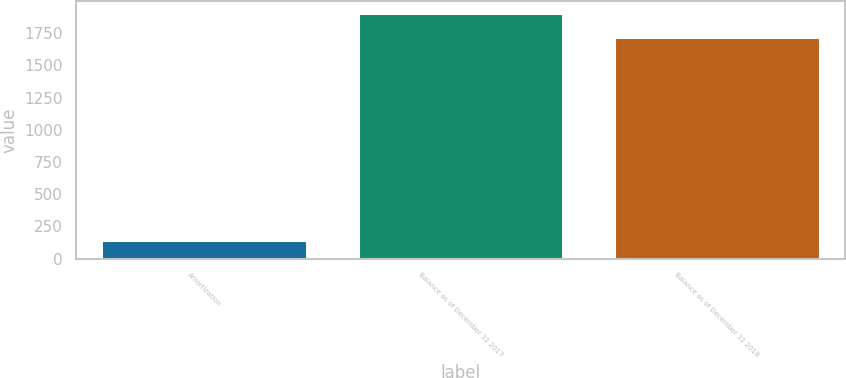Convert chart to OTSL. <chart><loc_0><loc_0><loc_500><loc_500><bar_chart><fcel>Amortization<fcel>Balance as of December 31 2017<fcel>Balance as of December 31 2018<nl><fcel>142.9<fcel>1902.6<fcel>1720.2<nl></chart> 